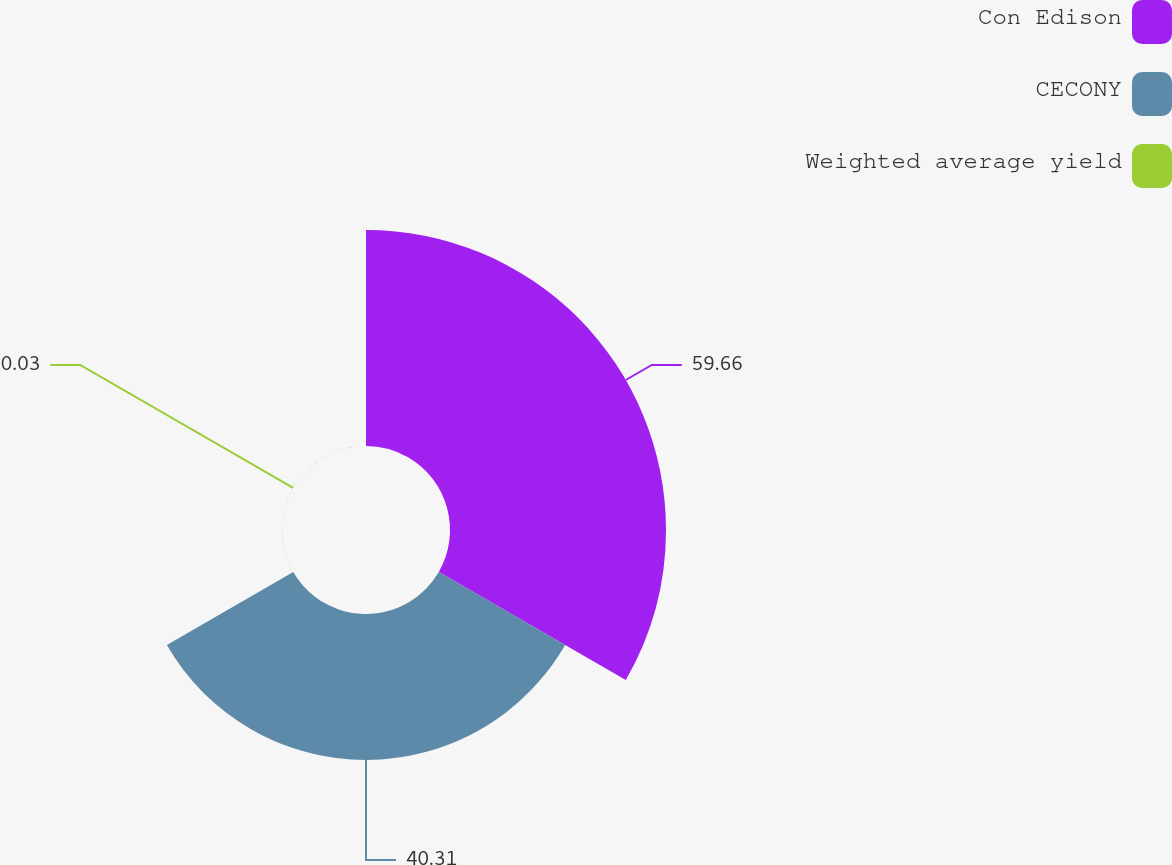Convert chart. <chart><loc_0><loc_0><loc_500><loc_500><pie_chart><fcel>Con Edison<fcel>CECONY<fcel>Weighted average yield<nl><fcel>59.66%<fcel>40.31%<fcel>0.03%<nl></chart> 